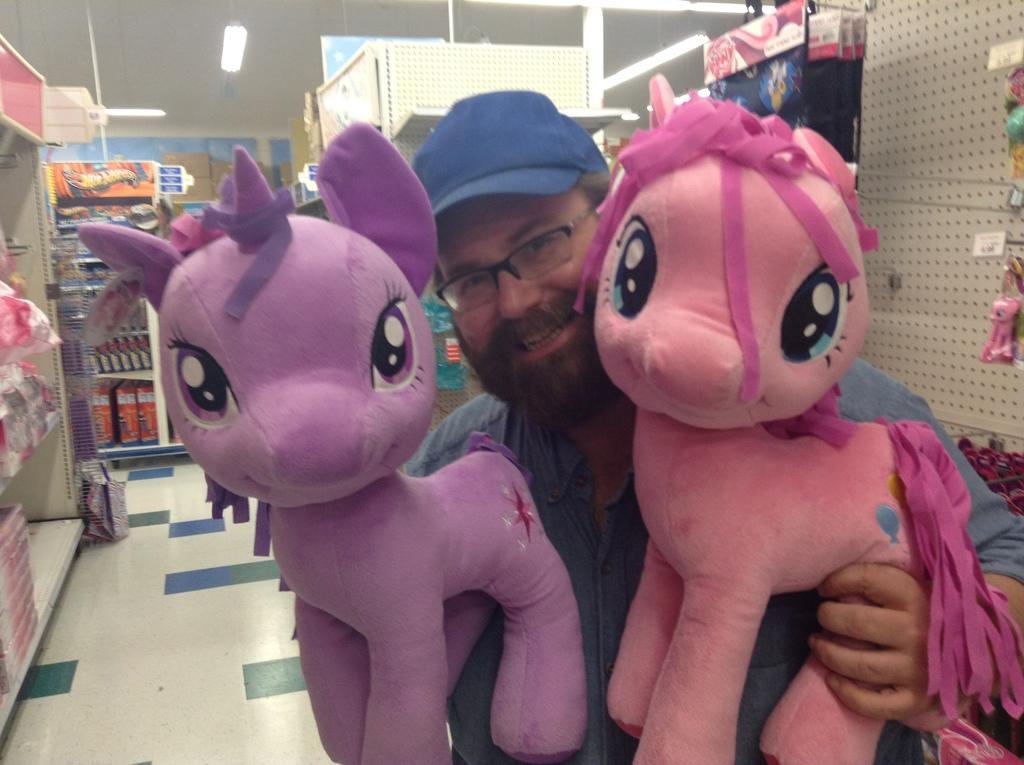Please provide a concise description of this image. In the middle of the image a person is standing and holding two toys and smiling. Behind him we can see some racks, in the racks we can see some toys. At the top of the image we can see ceiling, on the ceiling we can see some lights. 